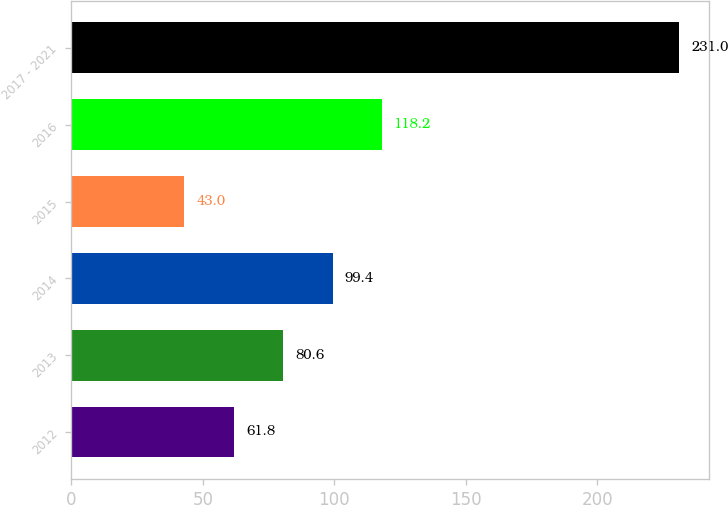<chart> <loc_0><loc_0><loc_500><loc_500><bar_chart><fcel>2012<fcel>2013<fcel>2014<fcel>2015<fcel>2016<fcel>2017 - 2021<nl><fcel>61.8<fcel>80.6<fcel>99.4<fcel>43<fcel>118.2<fcel>231<nl></chart> 